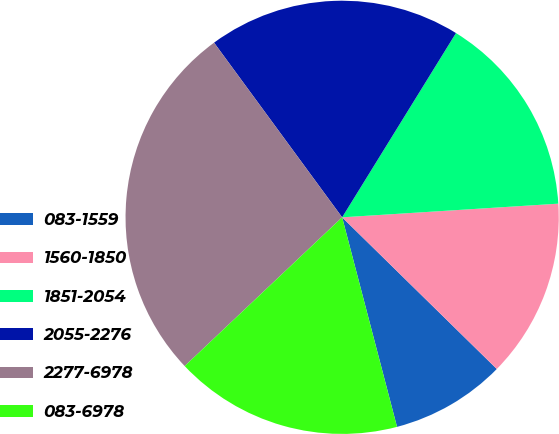<chart> <loc_0><loc_0><loc_500><loc_500><pie_chart><fcel>083-1559<fcel>1560-1850<fcel>1851-2054<fcel>2055-2276<fcel>2277-6978<fcel>083-6978<nl><fcel>8.58%<fcel>13.35%<fcel>15.19%<fcel>18.88%<fcel>26.98%<fcel>17.03%<nl></chart> 